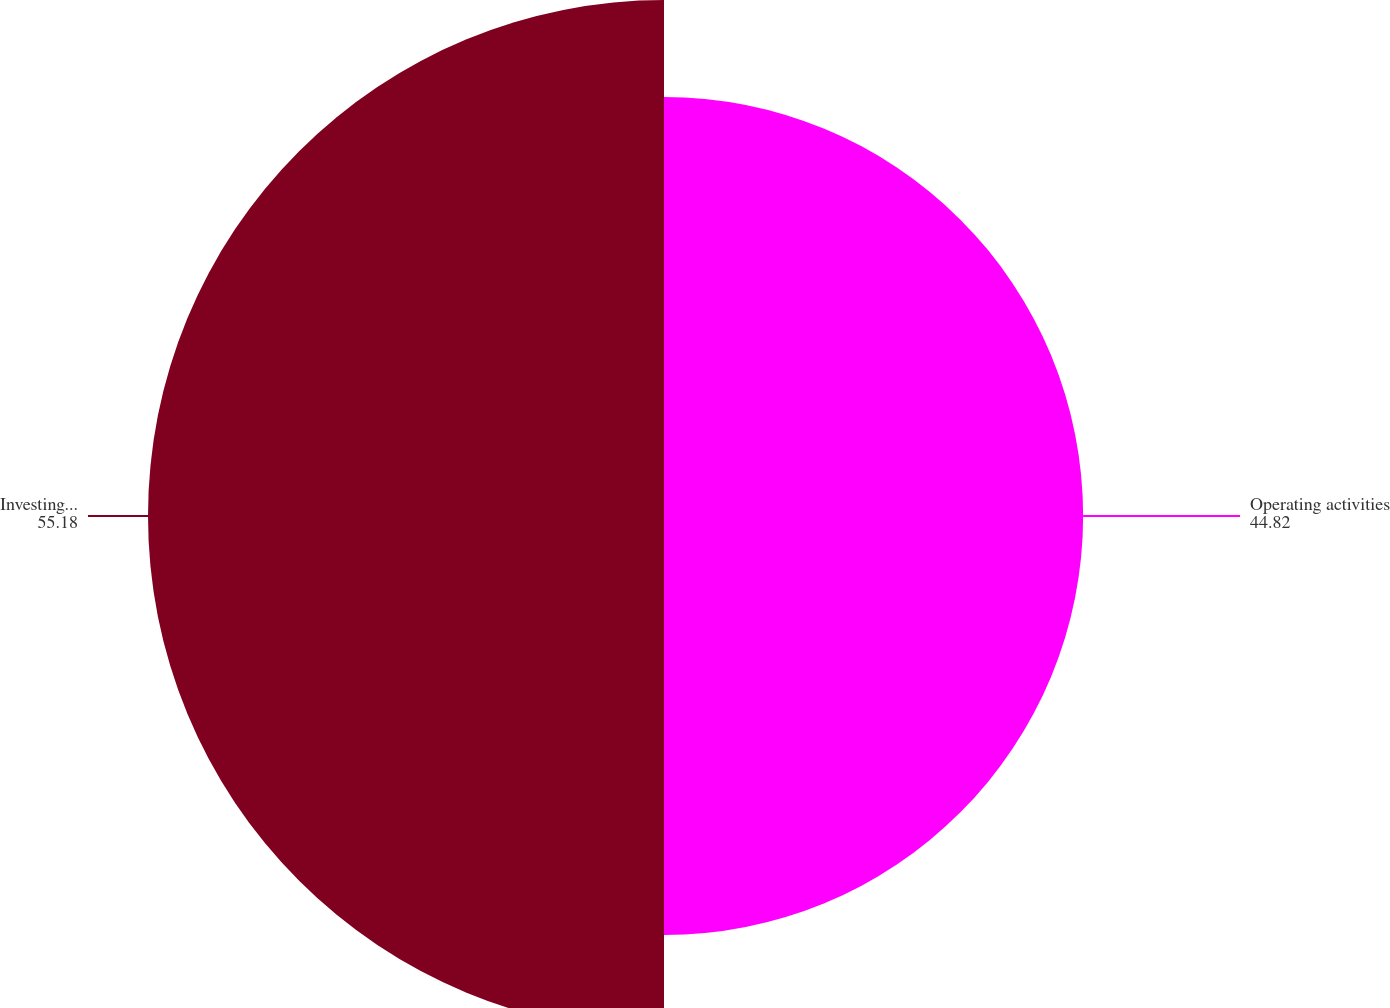Convert chart to OTSL. <chart><loc_0><loc_0><loc_500><loc_500><pie_chart><fcel>Operating activities<fcel>Investing activities<nl><fcel>44.82%<fcel>55.18%<nl></chart> 